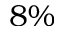<formula> <loc_0><loc_0><loc_500><loc_500>8 \%</formula> 